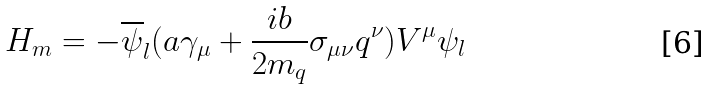Convert formula to latex. <formula><loc_0><loc_0><loc_500><loc_500>H _ { m } = - \overline { \psi } _ { l } ( a \gamma _ { \mu } + \frac { i b } { 2 m _ { q } } \sigma _ { \mu \nu } q ^ { \nu } ) V ^ { \mu } \psi _ { l } \,</formula> 